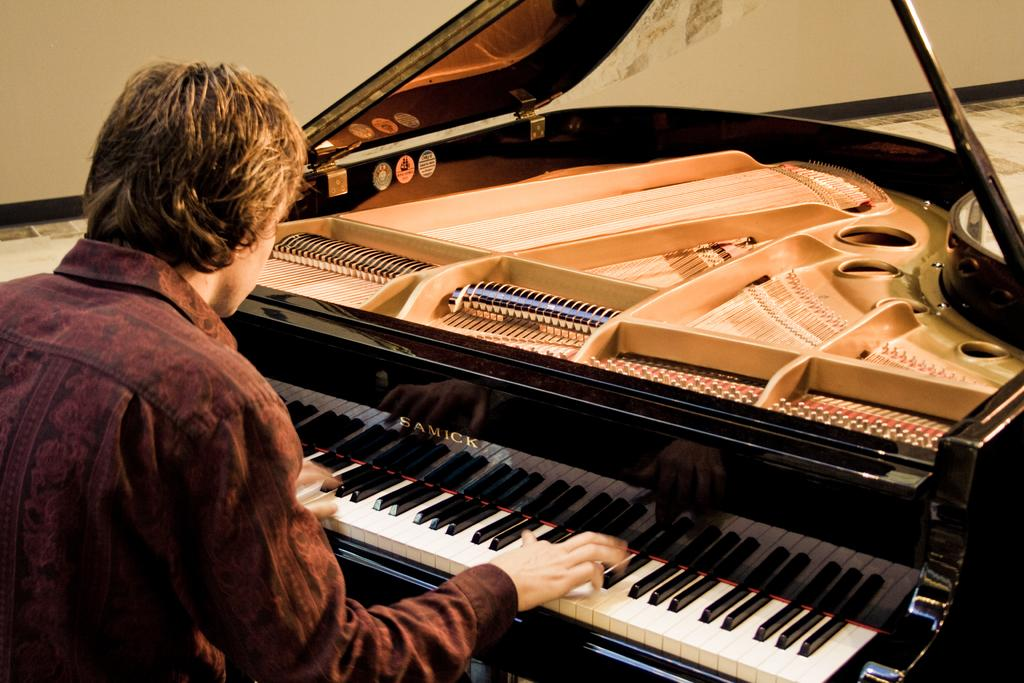What is the person in the image doing? The person is playing the piano. What is the person wearing in the image? The person is wearing a brown shirt. What is the color of the piano in the image? The piano's color is brown. What invention is the person using to support their wrist while playing the piano? There is no invention visible in the image to support the person's wrist while playing the piano. What type of trousers is the person wearing in the image? The provided facts do not mention the type of trousers the person is wearing, so we cannot answer this question definitively. 